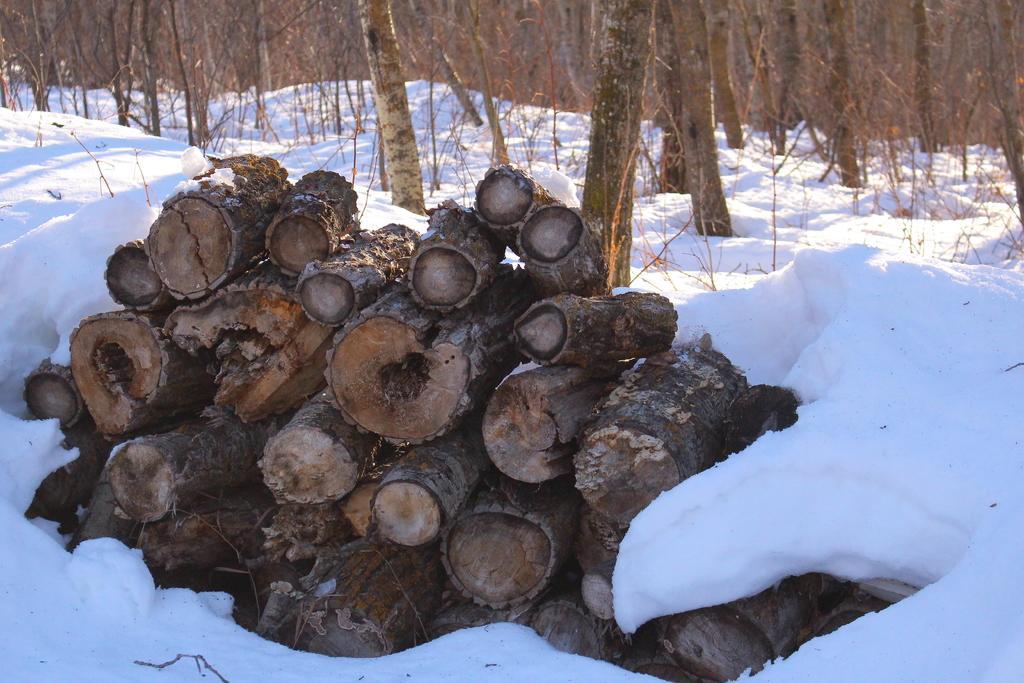Can you describe this image briefly? In this image I can see ground full of snow and on it I can see log of wood. In the background I can see number of trees. 